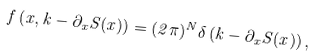Convert formula to latex. <formula><loc_0><loc_0><loc_500><loc_500>f \left ( x , k - \partial _ { x } S ( x ) \right ) = ( 2 \pi ) ^ { N } \delta \left ( k - \partial _ { x } S ( x ) \right ) ,</formula> 